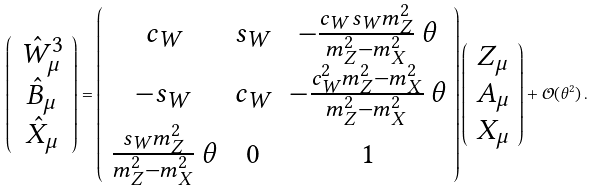Convert formula to latex. <formula><loc_0><loc_0><loc_500><loc_500>\left ( \begin{array} { c } \hat { W } ^ { 3 } _ { \mu } \\ \hat { B } _ { \mu } \\ \hat { X } _ { \mu } \\ \end{array} \right ) = \left ( \begin{array} { c c c } c _ { W } & s _ { W } & - \frac { c _ { W } s _ { W } m _ { Z } ^ { 2 } } { m _ { Z } ^ { 2 } - m _ { X } ^ { 2 } } \, \theta \\ - s _ { W } & c _ { W } & - \frac { c _ { W } ^ { 2 } m _ { Z } ^ { 2 } - m _ { X } ^ { 2 } } { m _ { Z } ^ { 2 } - m _ { X } ^ { 2 } } \, \theta \\ \frac { s _ { W } m _ { Z } ^ { 2 } } { m _ { Z } ^ { 2 } - m _ { X } ^ { 2 } } \, \theta & 0 & 1 \\ \end{array} \right ) \left ( \begin{array} { c } Z _ { \mu } \\ A _ { \mu } \\ X _ { \mu } \\ \end{array} \right ) + \mathcal { O } ( \theta ^ { 2 } ) \, .</formula> 